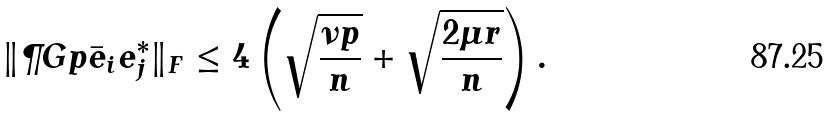Convert formula to latex. <formula><loc_0><loc_0><loc_500><loc_500>\| \P G p \bar { e } _ { i } e _ { j } ^ { * } \| _ { F } \leq 4 \left ( \sqrt { \frac { \nu p } { n } } + \sqrt { \frac { 2 \mu r } { n } } \right ) .</formula> 